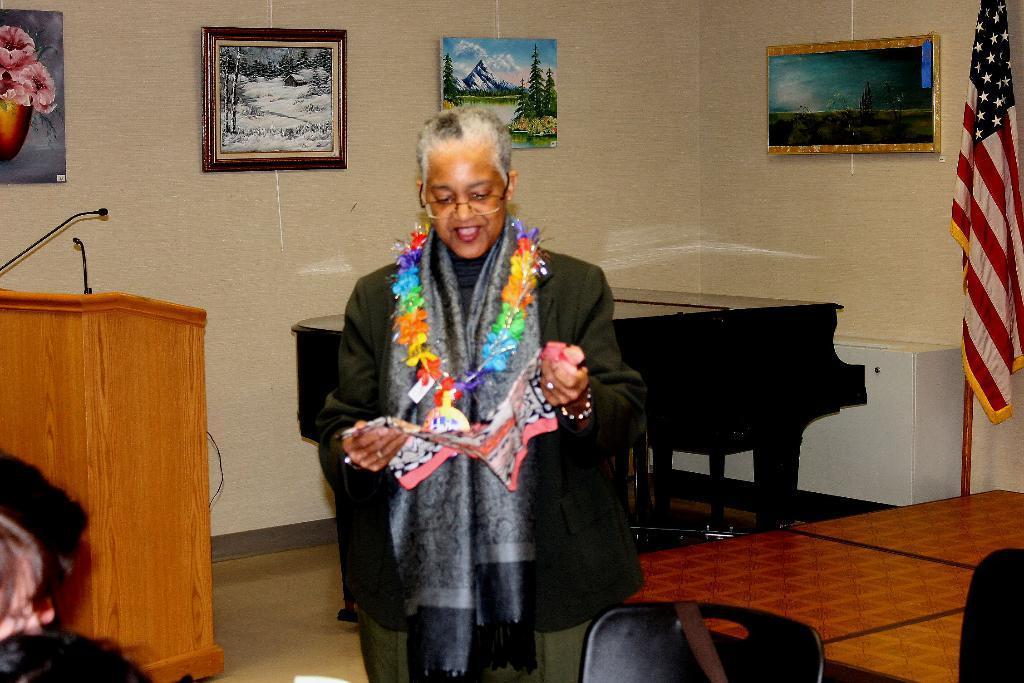Please provide a concise description of this image. This is a picture taken from inside of a room and a woman stand wearing a black color jacket ,she is smiling and there are the photo frames on the wall and there is a podium on the right side an don the left side there is a flag and there is a chair on right corner. 